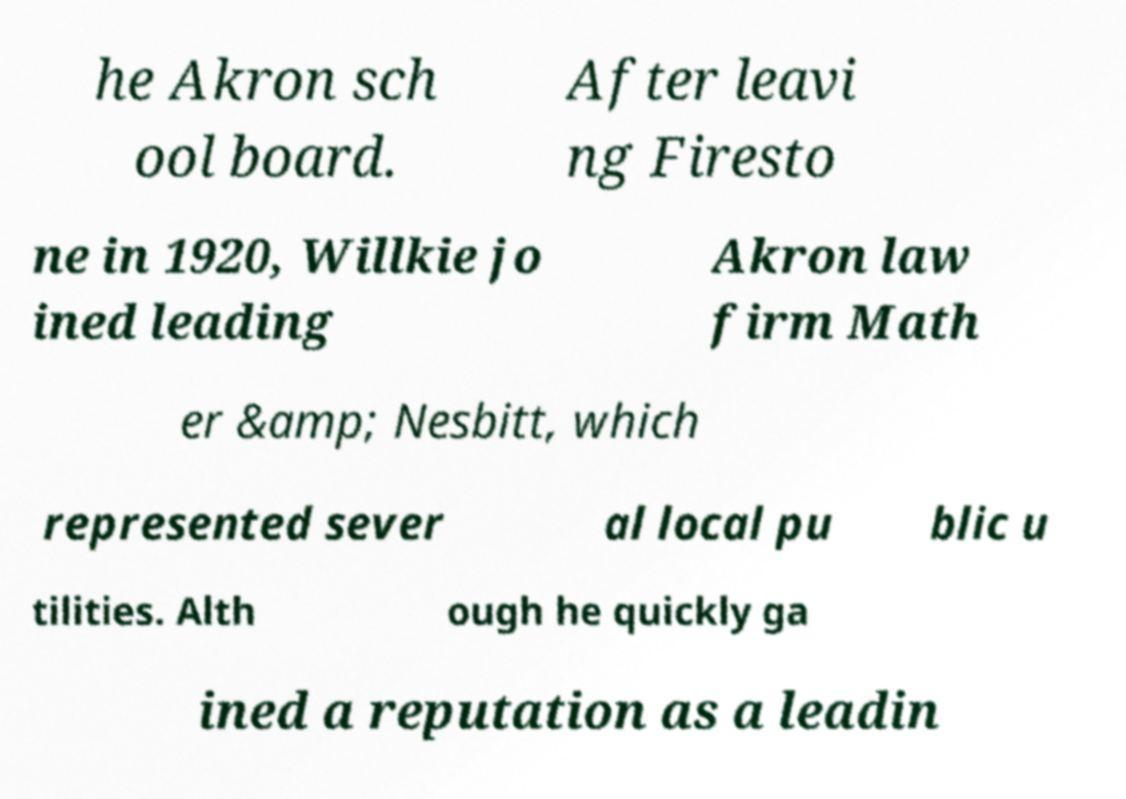I need the written content from this picture converted into text. Can you do that? he Akron sch ool board. After leavi ng Firesto ne in 1920, Willkie jo ined leading Akron law firm Math er &amp; Nesbitt, which represented sever al local pu blic u tilities. Alth ough he quickly ga ined a reputation as a leadin 